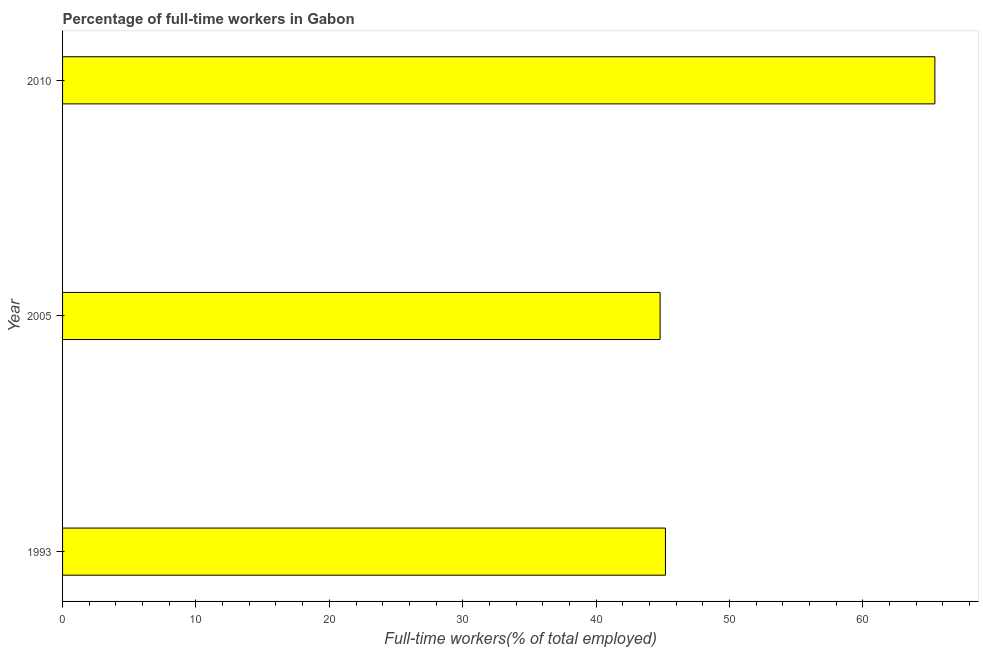What is the title of the graph?
Provide a short and direct response. Percentage of full-time workers in Gabon. What is the label or title of the X-axis?
Provide a short and direct response. Full-time workers(% of total employed). What is the label or title of the Y-axis?
Provide a short and direct response. Year. What is the percentage of full-time workers in 1993?
Keep it short and to the point. 45.2. Across all years, what is the maximum percentage of full-time workers?
Keep it short and to the point. 65.4. Across all years, what is the minimum percentage of full-time workers?
Your answer should be compact. 44.8. What is the sum of the percentage of full-time workers?
Offer a terse response. 155.4. What is the difference between the percentage of full-time workers in 1993 and 2010?
Keep it short and to the point. -20.2. What is the average percentage of full-time workers per year?
Make the answer very short. 51.8. What is the median percentage of full-time workers?
Provide a short and direct response. 45.2. In how many years, is the percentage of full-time workers greater than 4 %?
Your answer should be compact. 3. Is the difference between the percentage of full-time workers in 1993 and 2005 greater than the difference between any two years?
Give a very brief answer. No. What is the difference between the highest and the second highest percentage of full-time workers?
Keep it short and to the point. 20.2. What is the difference between the highest and the lowest percentage of full-time workers?
Your answer should be very brief. 20.6. In how many years, is the percentage of full-time workers greater than the average percentage of full-time workers taken over all years?
Keep it short and to the point. 1. How many bars are there?
Provide a succinct answer. 3. How many years are there in the graph?
Give a very brief answer. 3. What is the difference between two consecutive major ticks on the X-axis?
Your answer should be very brief. 10. Are the values on the major ticks of X-axis written in scientific E-notation?
Provide a succinct answer. No. What is the Full-time workers(% of total employed) in 1993?
Your response must be concise. 45.2. What is the Full-time workers(% of total employed) of 2005?
Your answer should be compact. 44.8. What is the Full-time workers(% of total employed) of 2010?
Your answer should be compact. 65.4. What is the difference between the Full-time workers(% of total employed) in 1993 and 2005?
Provide a short and direct response. 0.4. What is the difference between the Full-time workers(% of total employed) in 1993 and 2010?
Ensure brevity in your answer.  -20.2. What is the difference between the Full-time workers(% of total employed) in 2005 and 2010?
Your response must be concise. -20.6. What is the ratio of the Full-time workers(% of total employed) in 1993 to that in 2010?
Offer a very short reply. 0.69. What is the ratio of the Full-time workers(% of total employed) in 2005 to that in 2010?
Keep it short and to the point. 0.69. 